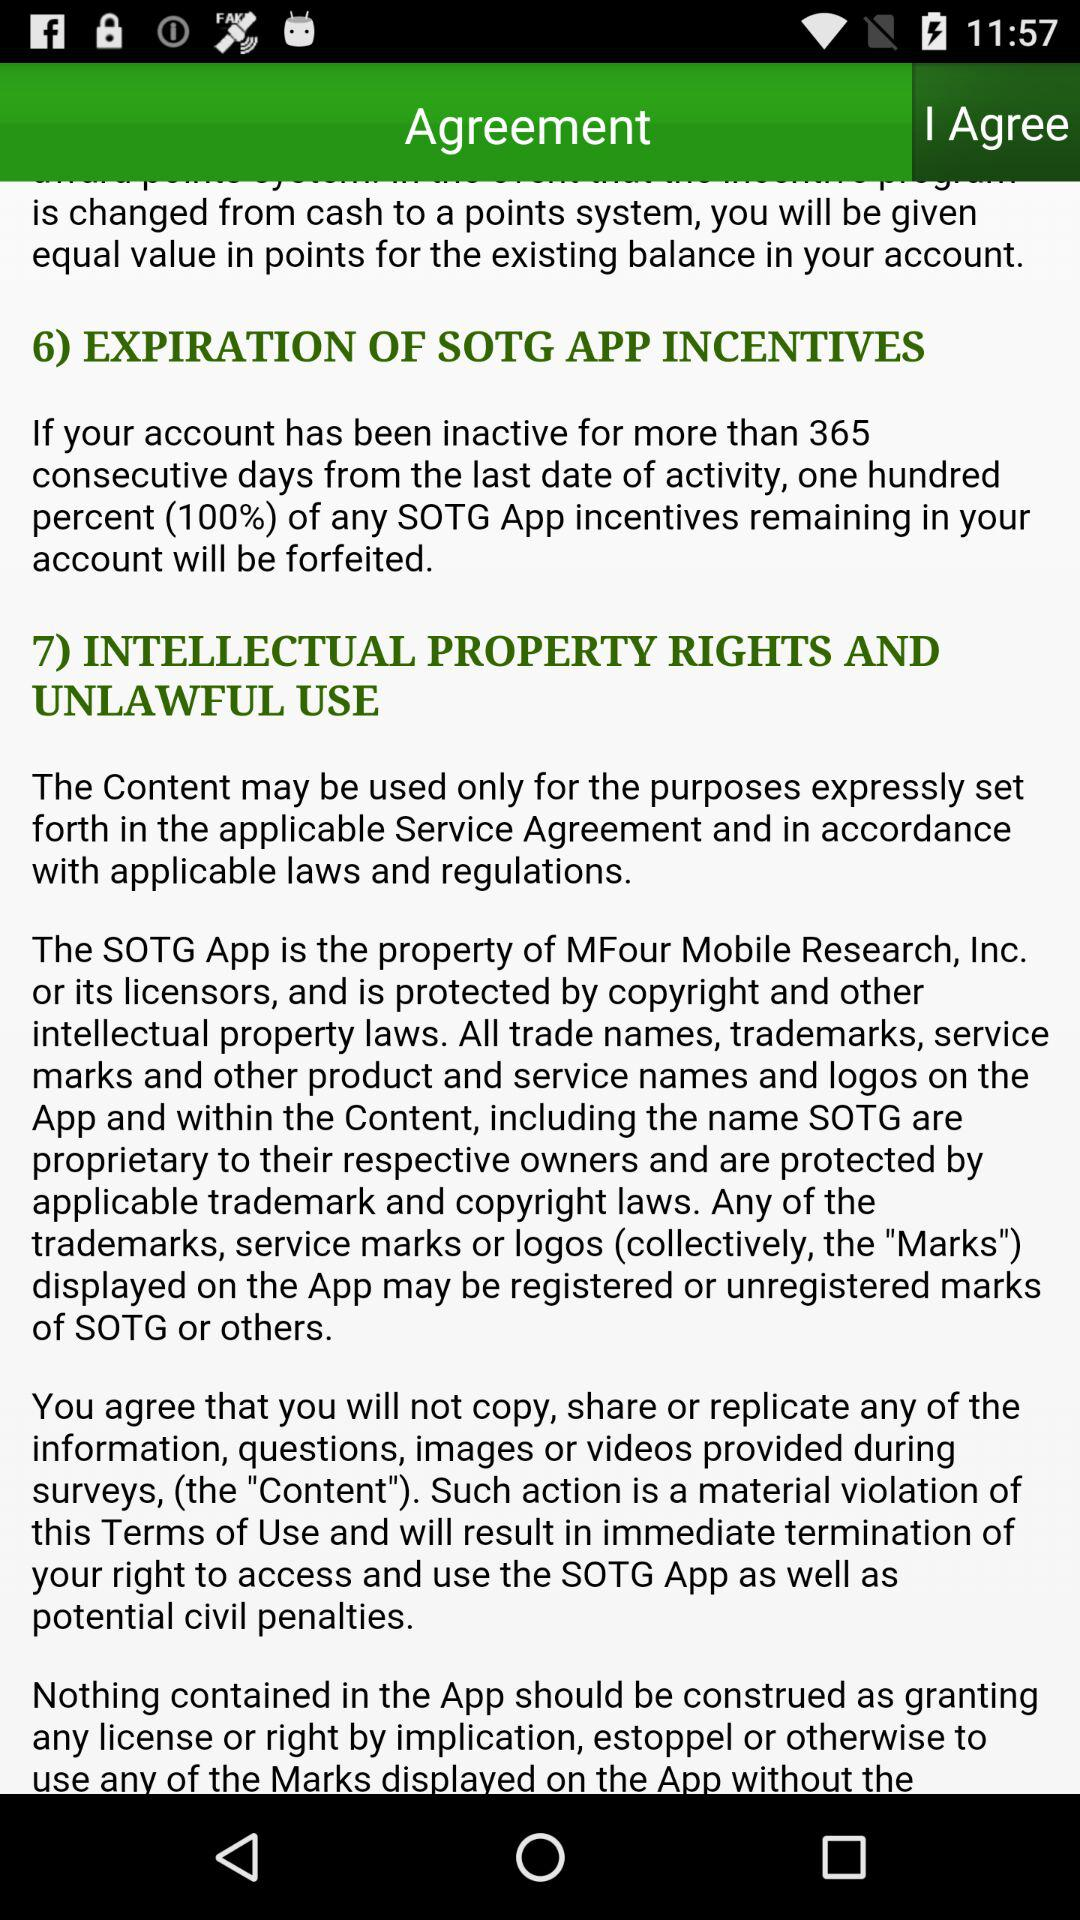How many sections are there in the Terms of Use document?
Answer the question using a single word or phrase. 7 